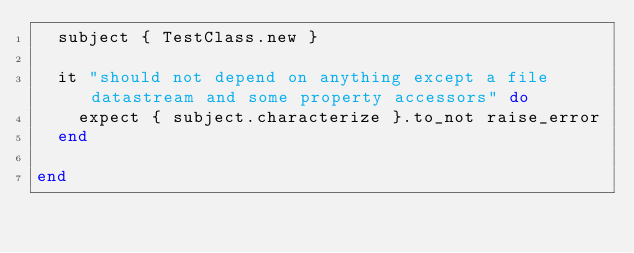<code> <loc_0><loc_0><loc_500><loc_500><_Ruby_>  subject { TestClass.new }

  it "should not depend on anything except a file datastream and some property accessors" do
    expect { subject.characterize }.to_not raise_error
  end

end
</code> 